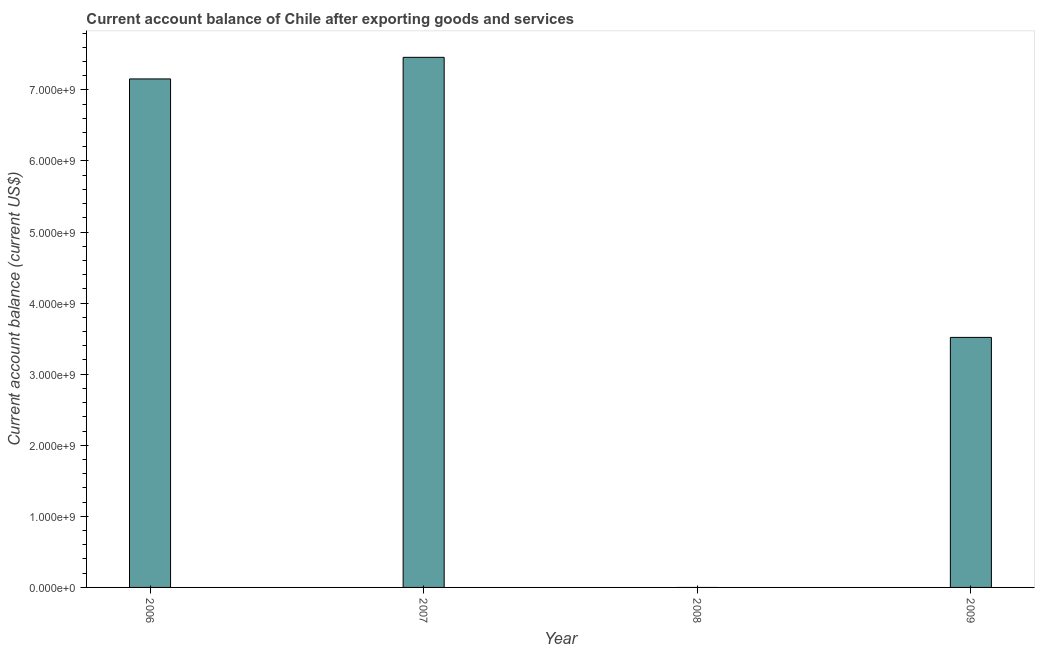Does the graph contain any zero values?
Make the answer very short. Yes. What is the title of the graph?
Offer a very short reply. Current account balance of Chile after exporting goods and services. What is the label or title of the Y-axis?
Give a very brief answer. Current account balance (current US$). What is the current account balance in 2006?
Make the answer very short. 7.15e+09. Across all years, what is the maximum current account balance?
Keep it short and to the point. 7.46e+09. What is the sum of the current account balance?
Provide a succinct answer. 1.81e+1. What is the difference between the current account balance in 2007 and 2009?
Keep it short and to the point. 3.94e+09. What is the average current account balance per year?
Offer a terse response. 4.53e+09. What is the median current account balance?
Your answer should be compact. 5.34e+09. In how many years, is the current account balance greater than 3200000000 US$?
Keep it short and to the point. 3. What is the ratio of the current account balance in 2006 to that in 2009?
Your answer should be very brief. 2.03. What is the difference between the highest and the second highest current account balance?
Offer a terse response. 3.04e+08. What is the difference between the highest and the lowest current account balance?
Make the answer very short. 7.46e+09. In how many years, is the current account balance greater than the average current account balance taken over all years?
Ensure brevity in your answer.  2. How many bars are there?
Provide a short and direct response. 3. How many years are there in the graph?
Your response must be concise. 4. What is the Current account balance (current US$) of 2006?
Your response must be concise. 7.15e+09. What is the Current account balance (current US$) of 2007?
Provide a short and direct response. 7.46e+09. What is the Current account balance (current US$) of 2009?
Your answer should be very brief. 3.52e+09. What is the difference between the Current account balance (current US$) in 2006 and 2007?
Offer a very short reply. -3.04e+08. What is the difference between the Current account balance (current US$) in 2006 and 2009?
Provide a succinct answer. 3.64e+09. What is the difference between the Current account balance (current US$) in 2007 and 2009?
Ensure brevity in your answer.  3.94e+09. What is the ratio of the Current account balance (current US$) in 2006 to that in 2007?
Offer a very short reply. 0.96. What is the ratio of the Current account balance (current US$) in 2006 to that in 2009?
Your answer should be very brief. 2.03. What is the ratio of the Current account balance (current US$) in 2007 to that in 2009?
Your response must be concise. 2.12. 